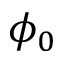<formula> <loc_0><loc_0><loc_500><loc_500>\phi _ { 0 }</formula> 